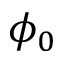<formula> <loc_0><loc_0><loc_500><loc_500>\phi _ { 0 }</formula> 